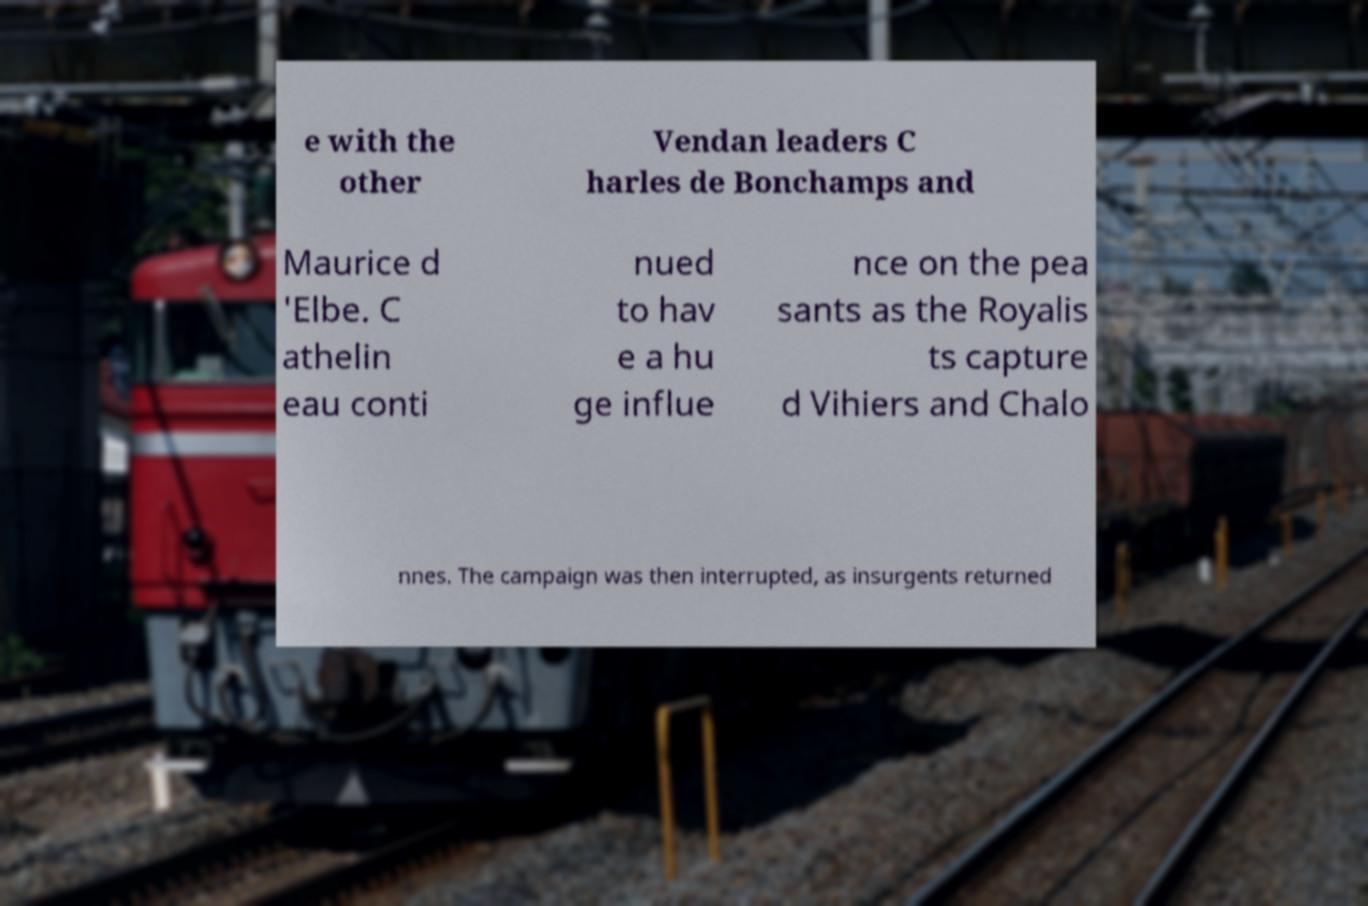Could you assist in decoding the text presented in this image and type it out clearly? e with the other Vendan leaders C harles de Bonchamps and Maurice d 'Elbe. C athelin eau conti nued to hav e a hu ge influe nce on the pea sants as the Royalis ts capture d Vihiers and Chalo nnes. The campaign was then interrupted, as insurgents returned 